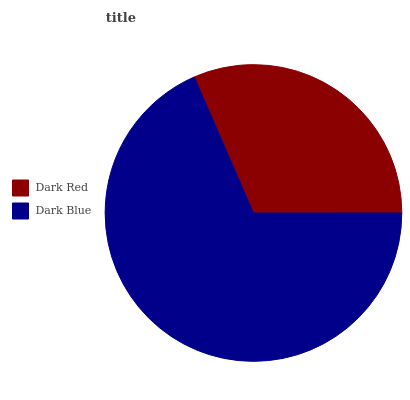Is Dark Red the minimum?
Answer yes or no. Yes. Is Dark Blue the maximum?
Answer yes or no. Yes. Is Dark Blue the minimum?
Answer yes or no. No. Is Dark Blue greater than Dark Red?
Answer yes or no. Yes. Is Dark Red less than Dark Blue?
Answer yes or no. Yes. Is Dark Red greater than Dark Blue?
Answer yes or no. No. Is Dark Blue less than Dark Red?
Answer yes or no. No. Is Dark Blue the high median?
Answer yes or no. Yes. Is Dark Red the low median?
Answer yes or no. Yes. Is Dark Red the high median?
Answer yes or no. No. Is Dark Blue the low median?
Answer yes or no. No. 